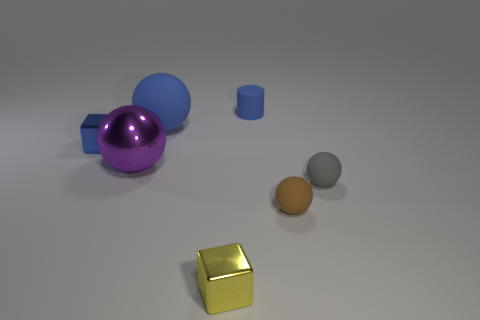There is a rubber sphere that is behind the small blue metal thing; is its color the same as the matte cylinder?
Your response must be concise. Yes. What is the size of the sphere that is the same color as the matte cylinder?
Provide a short and direct response. Large. Is the color of the small rubber cylinder the same as the large rubber ball?
Provide a short and direct response. Yes. Is there a metallic block of the same color as the rubber cylinder?
Your answer should be very brief. Yes. There is a matte thing that is the same color as the tiny matte cylinder; what is its shape?
Provide a short and direct response. Sphere. Do the thing to the right of the tiny brown thing and the tiny yellow cube have the same material?
Provide a short and direct response. No. There is a ball to the left of the big blue matte ball; what size is it?
Your answer should be very brief. Large. There is a thing that is on the left side of the big purple thing; are there any tiny blocks to the right of it?
Offer a very short reply. Yes. There is a matte object to the left of the cylinder; does it have the same color as the tiny metallic object that is behind the tiny brown thing?
Ensure brevity in your answer.  Yes. What color is the large rubber object?
Keep it short and to the point. Blue. 